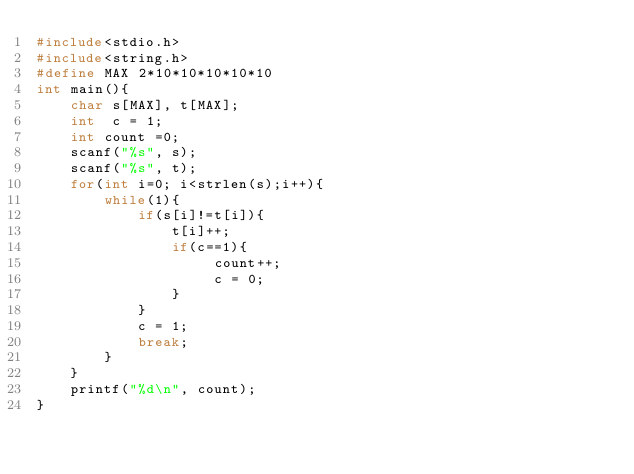<code> <loc_0><loc_0><loc_500><loc_500><_C_>#include<stdio.h>
#include<string.h>
#define MAX 2*10*10*10*10*10
int main(){
    char s[MAX], t[MAX];
    int  c = 1;
    int count =0;
    scanf("%s", s);
    scanf("%s", t);
    for(int i=0; i<strlen(s);i++){
        while(1){
            if(s[i]!=t[i]){
                t[i]++;
                if(c==1){
                     count++;
                     c = 0;
                }
            }
            c = 1;
            break;
        }
    }
    printf("%d\n", count);
}</code> 